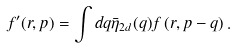<formula> <loc_0><loc_0><loc_500><loc_500>f ^ { \prime } ( r , p ) = \int d q \bar { \eta } _ { 2 d } ( q ) f \left ( r , p - q \right ) .</formula> 